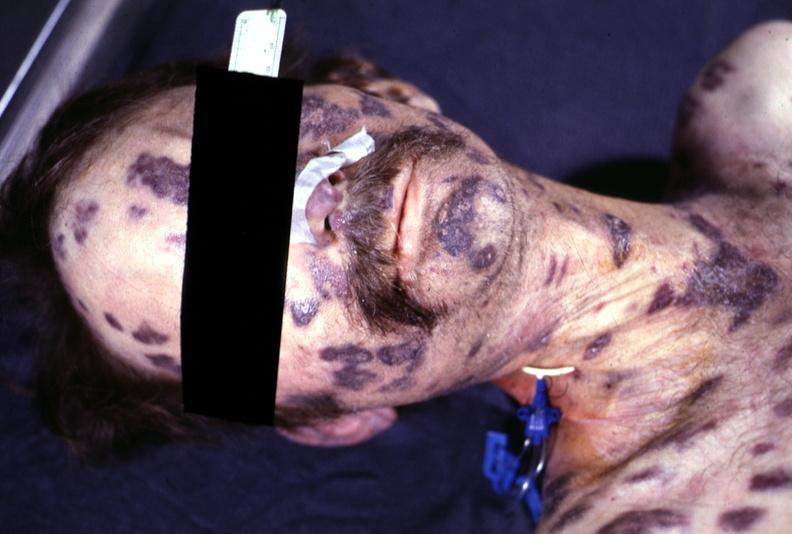does this image show skin, kaposi 's sarcoma?
Answer the question using a single word or phrase. Yes 